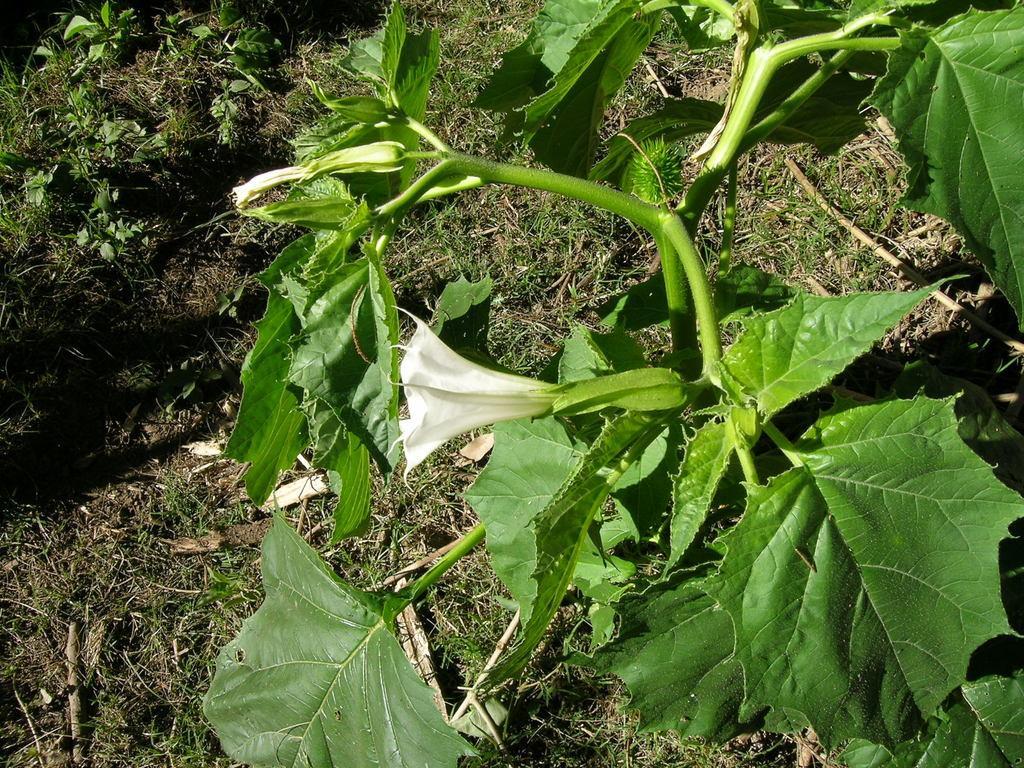Can you describe this image briefly? In this image there is a flower to one of the plant and grass. 